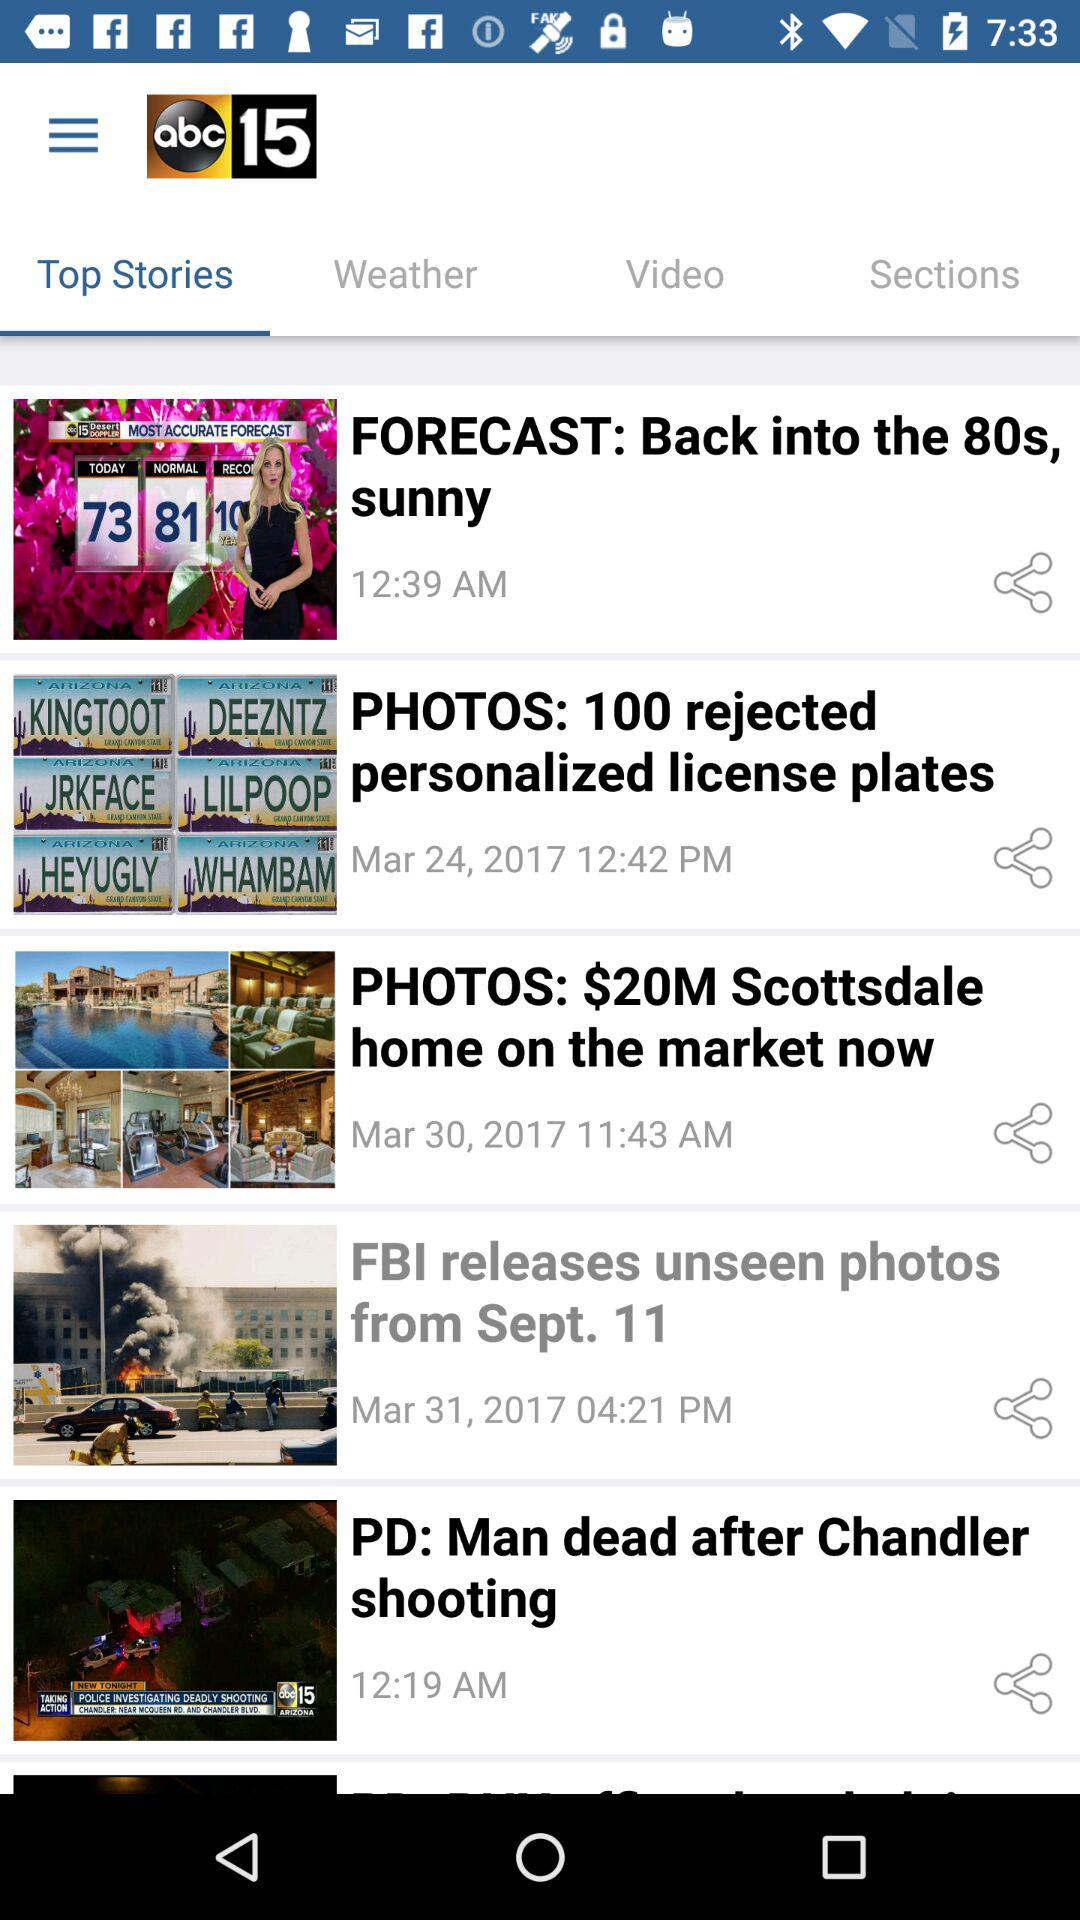What is the time for the story titled "PD: Man dead after Chandler shooting"? The time is 12:19 AM. 